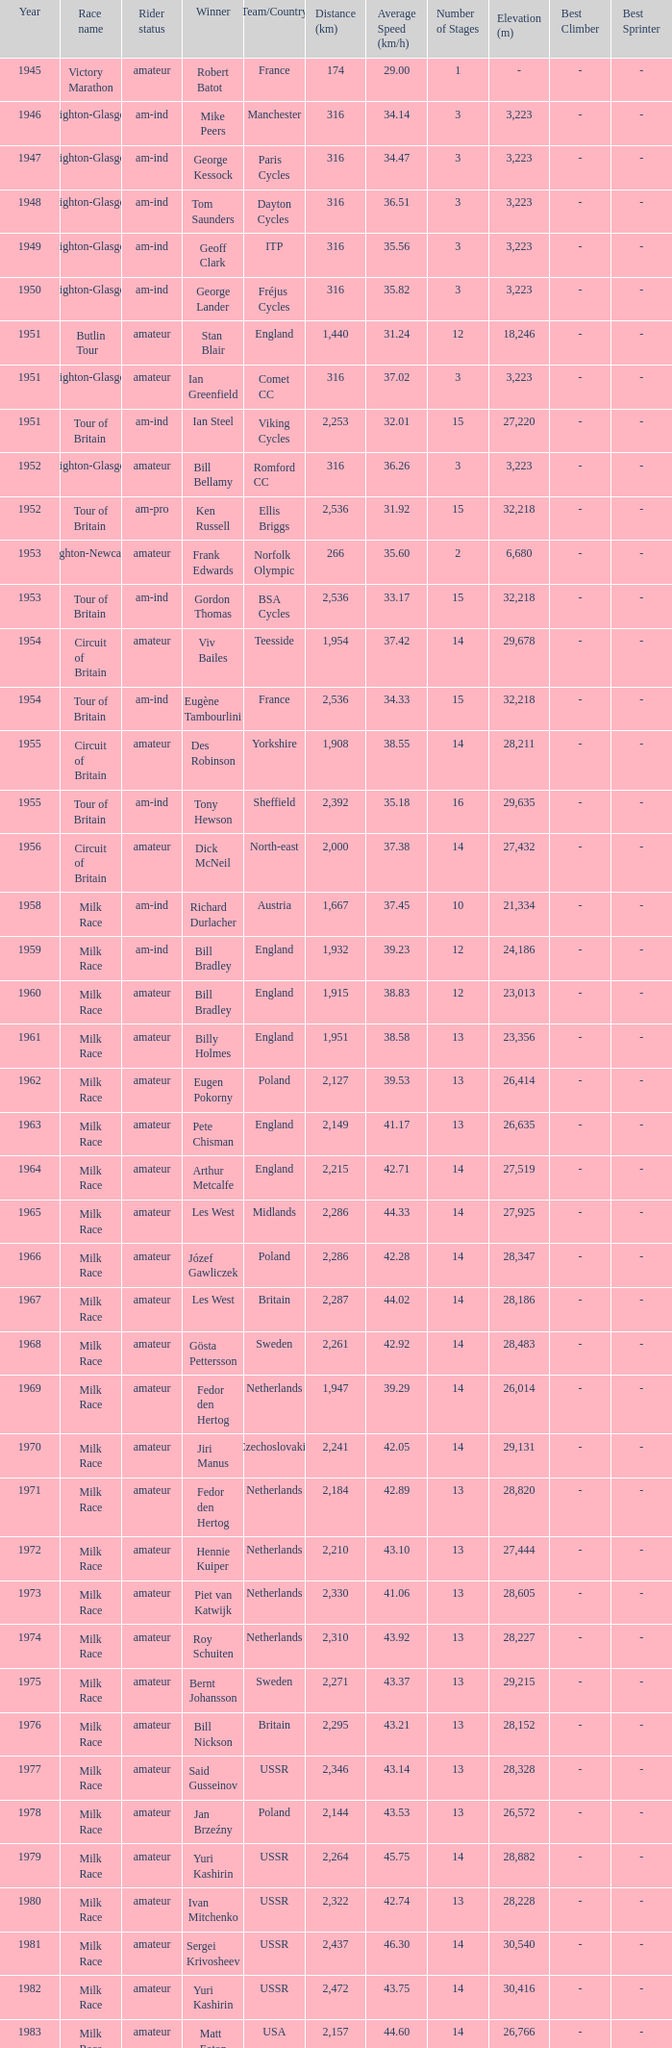Who was the winner in 1973 with an amateur rider status? Piet van Katwijk. 